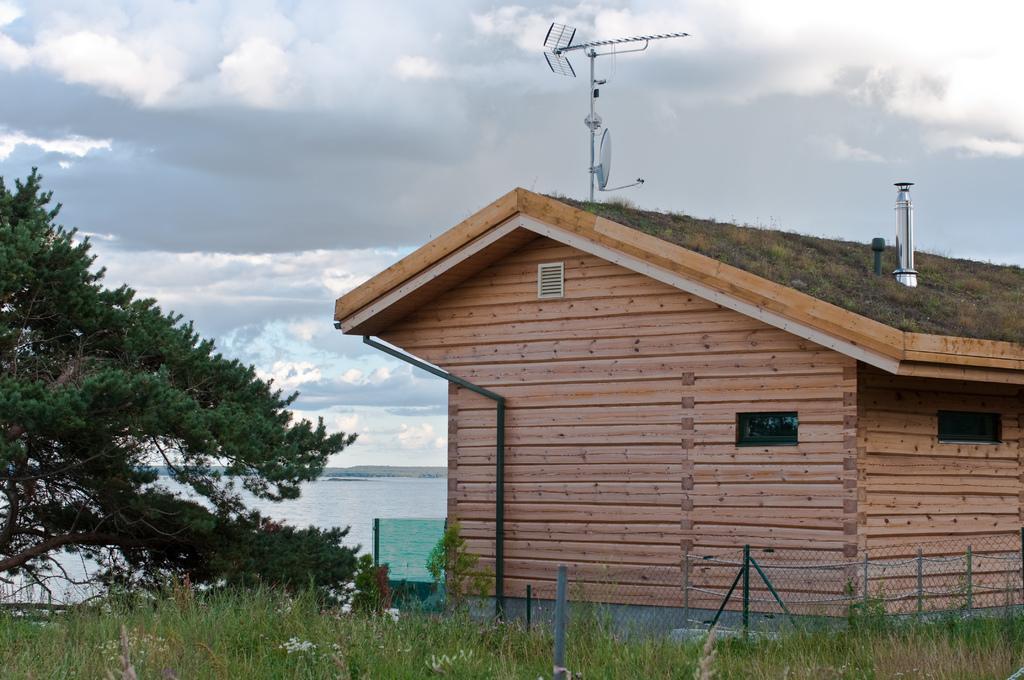In one or two sentences, can you explain what this image depicts? In this image we can see a house and on top of it there is antenna and fencing was done around the house. At the back side there is a river and at the left of the image there is a tree. At front there is a grass on the surface and at the background there is a sky. 